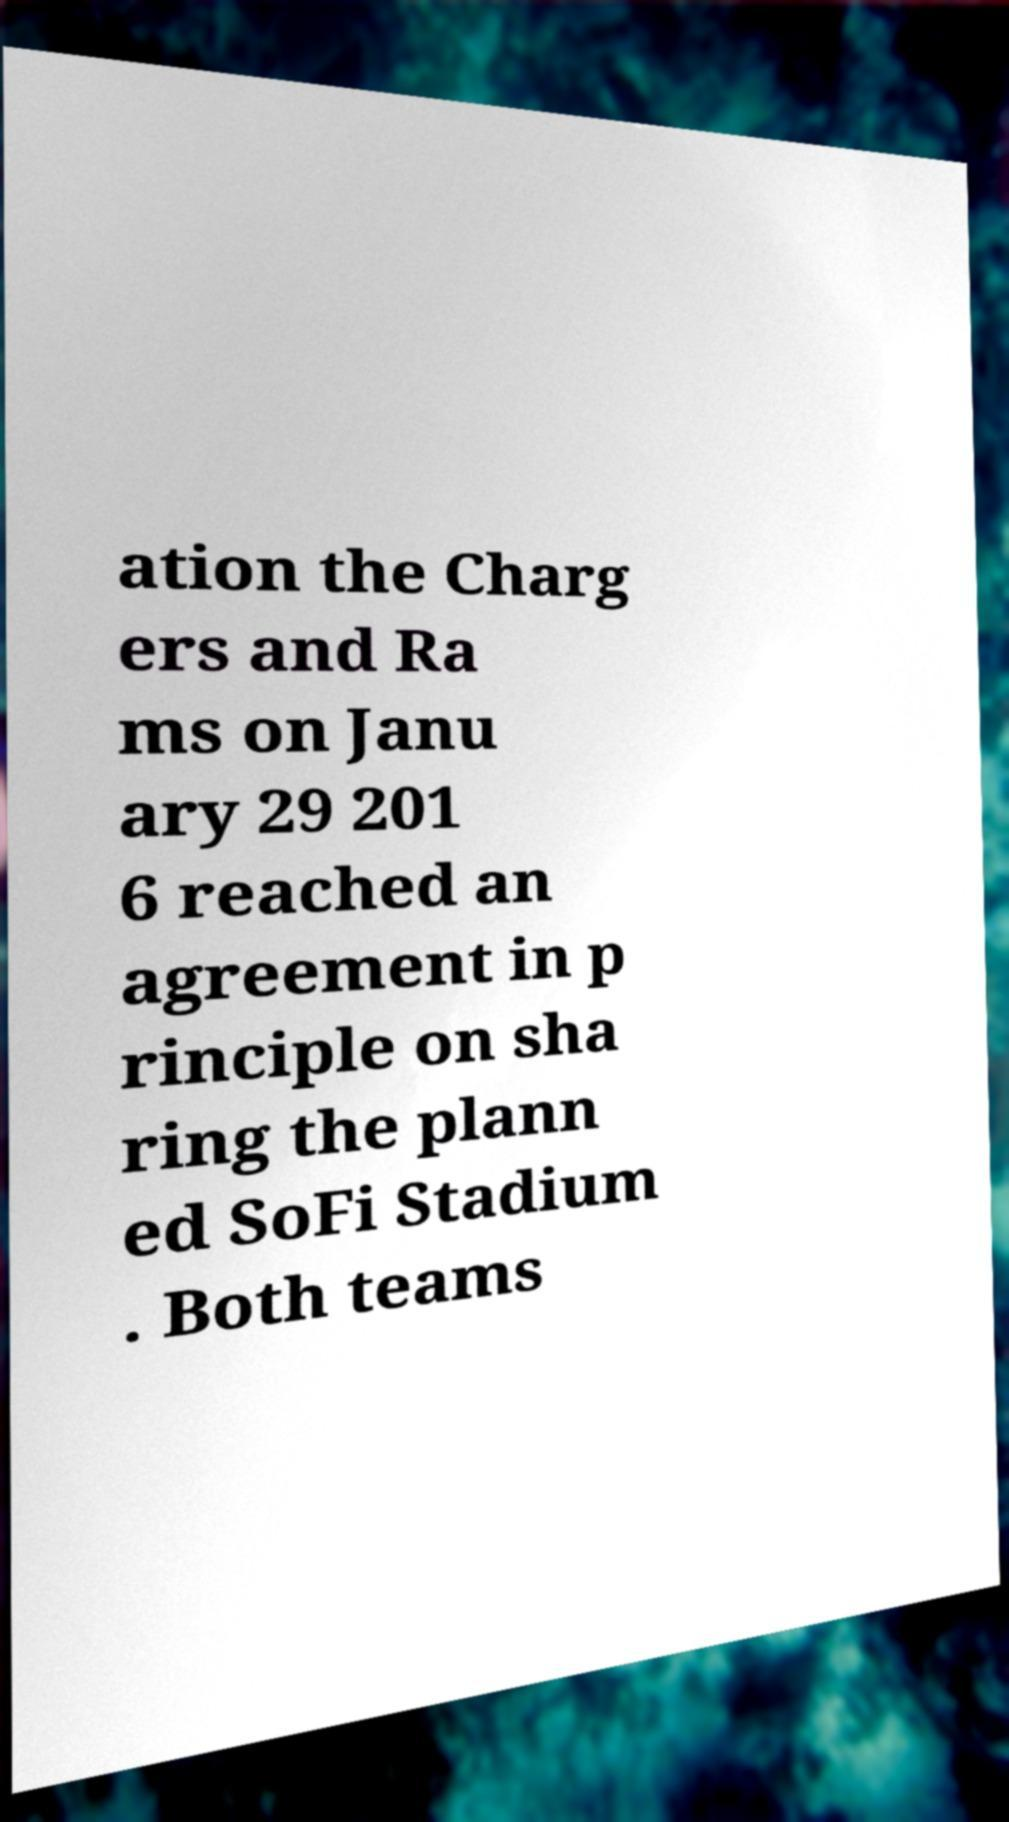I need the written content from this picture converted into text. Can you do that? ation the Charg ers and Ra ms on Janu ary 29 201 6 reached an agreement in p rinciple on sha ring the plann ed SoFi Stadium . Both teams 